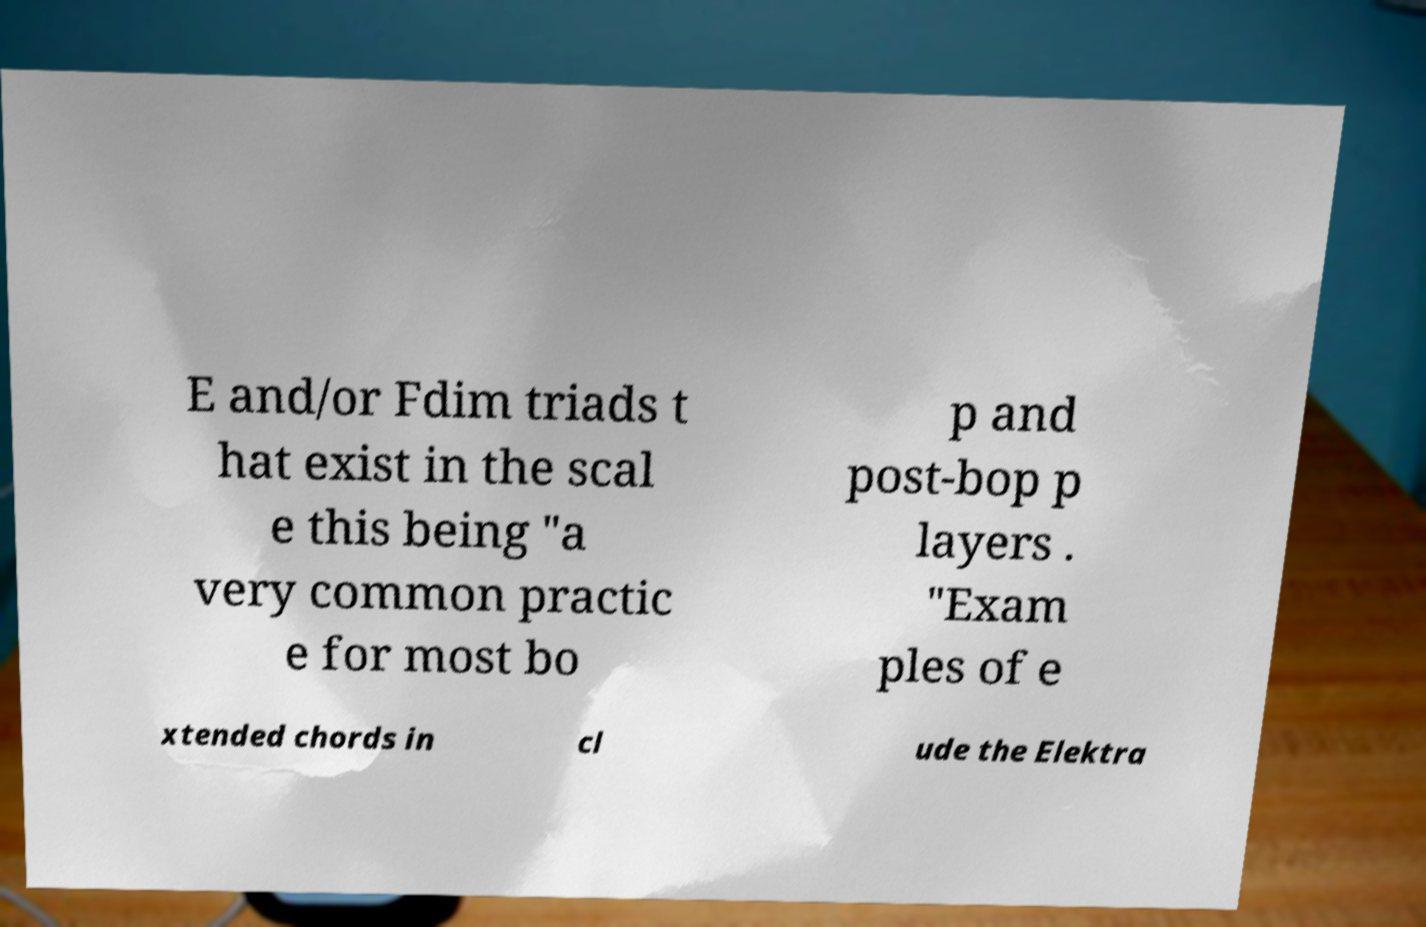For documentation purposes, I need the text within this image transcribed. Could you provide that? E and/or Fdim triads t hat exist in the scal e this being "a very common practic e for most bo p and post-bop p layers . "Exam ples of e xtended chords in cl ude the Elektra 